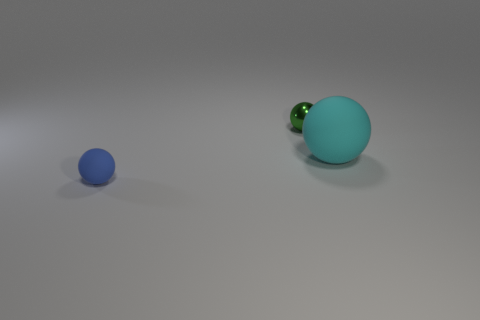Is there anything in the image that indicates what these balls might be used for? Nothing in the image explicitly indicates their use. Both balls appear as objects with no distinct features other than their color and size, so their purpose is not clear from the image alone. 